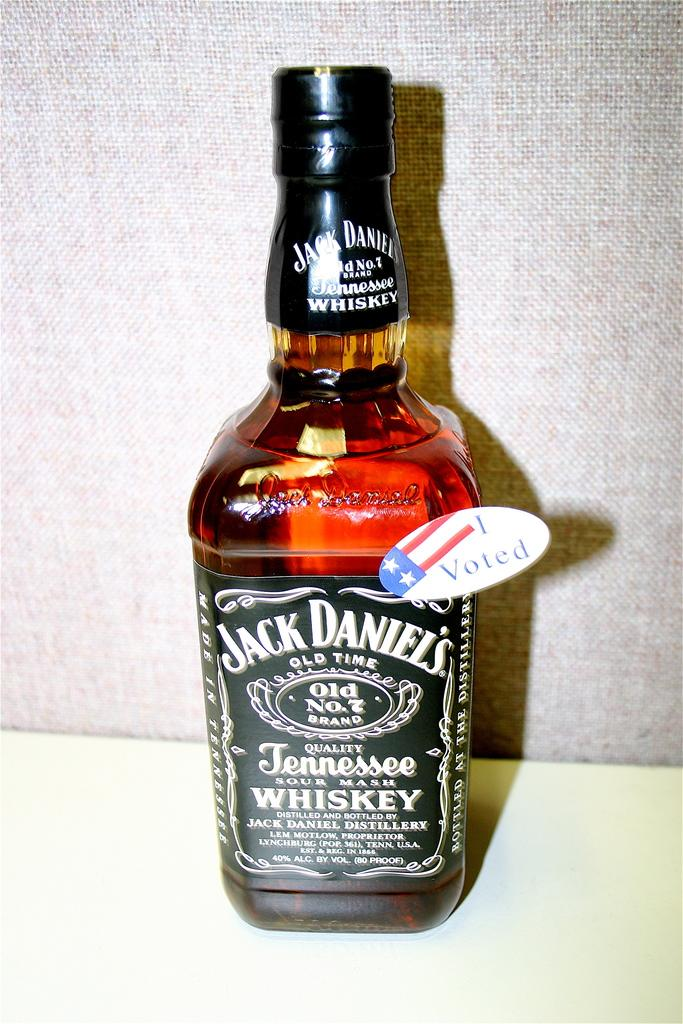<image>
Describe the image concisely. A bottle of Jack Daniel's has a pin on it that says I Voted. 